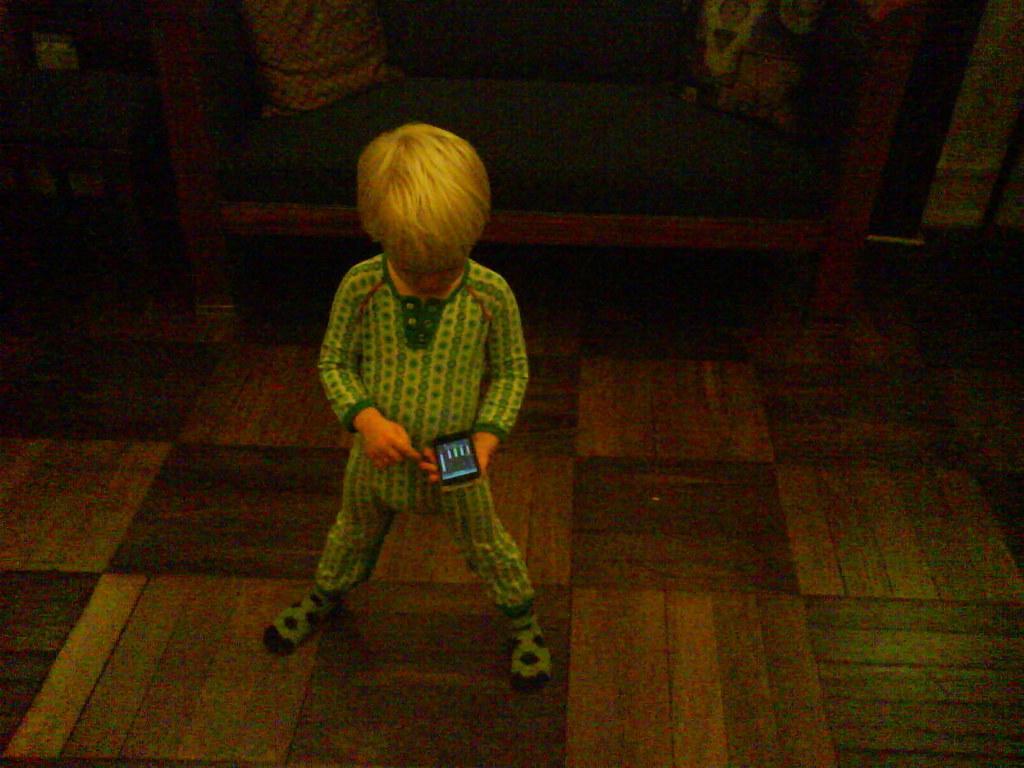In one or two sentences, can you explain what this image depicts? In the middles of the image, there is a child in green color dress, holding a mobile with one hand and standing on a floor. And the background is dark in color. 